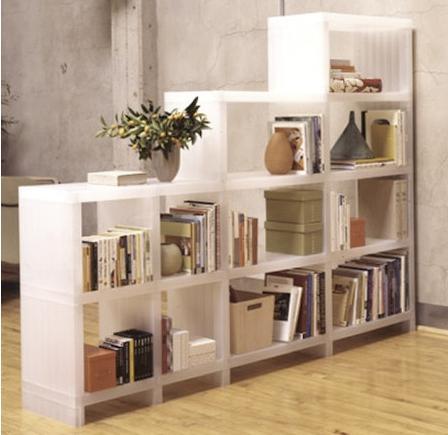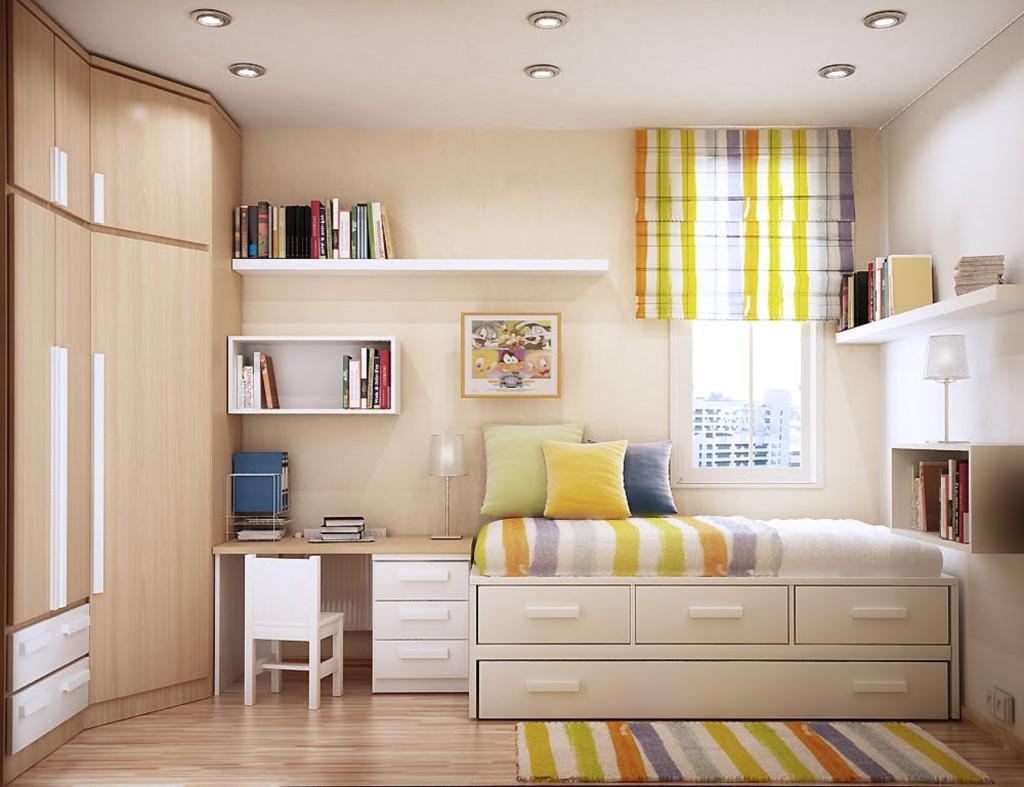The first image is the image on the left, the second image is the image on the right. Analyze the images presented: Is the assertion "In at least one image, there's a white shelf blocking a bed from view." valid? Answer yes or no. No. 